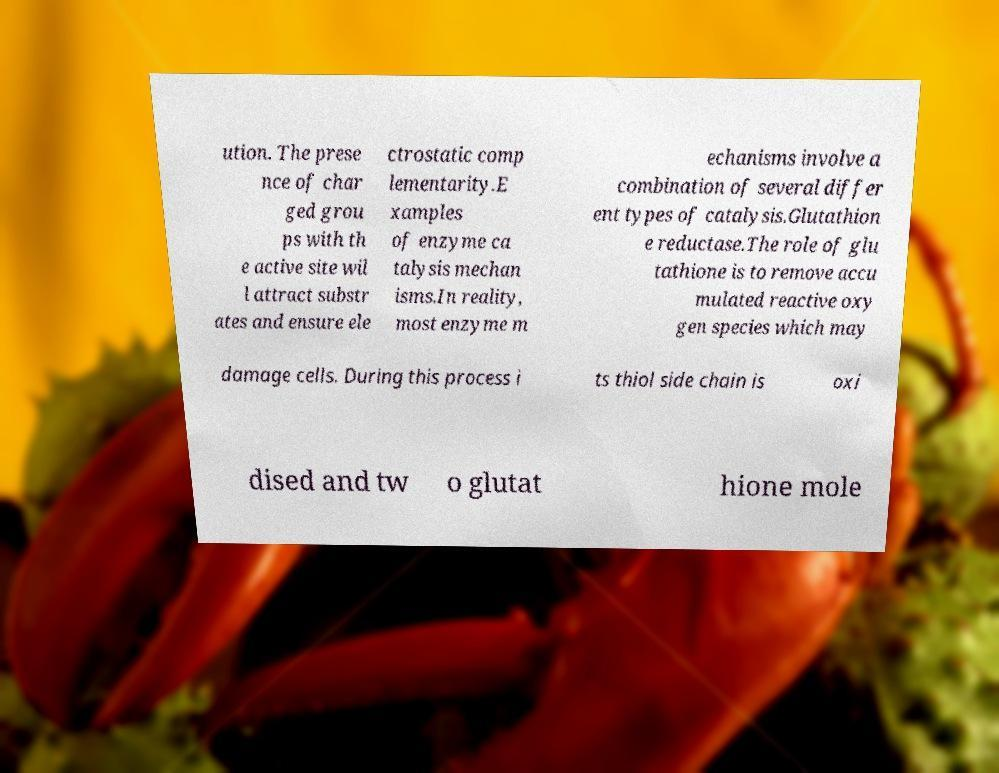Can you accurately transcribe the text from the provided image for me? ution. The prese nce of char ged grou ps with th e active site wil l attract substr ates and ensure ele ctrostatic comp lementarity.E xamples of enzyme ca talysis mechan isms.In reality, most enzyme m echanisms involve a combination of several differ ent types of catalysis.Glutathion e reductase.The role of glu tathione is to remove accu mulated reactive oxy gen species which may damage cells. During this process i ts thiol side chain is oxi dised and tw o glutat hione mole 